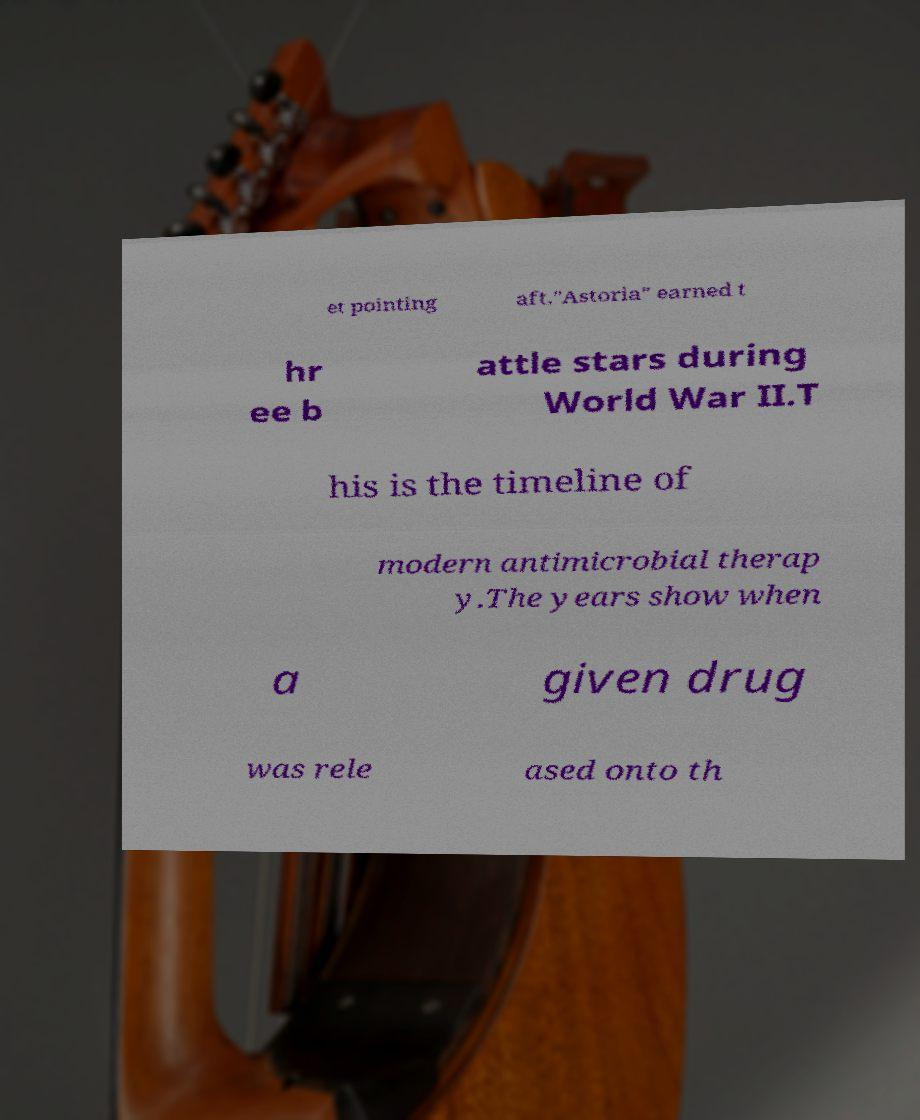Please read and relay the text visible in this image. What does it say? et pointing aft."Astoria" earned t hr ee b attle stars during World War II.T his is the timeline of modern antimicrobial therap y.The years show when a given drug was rele ased onto th 